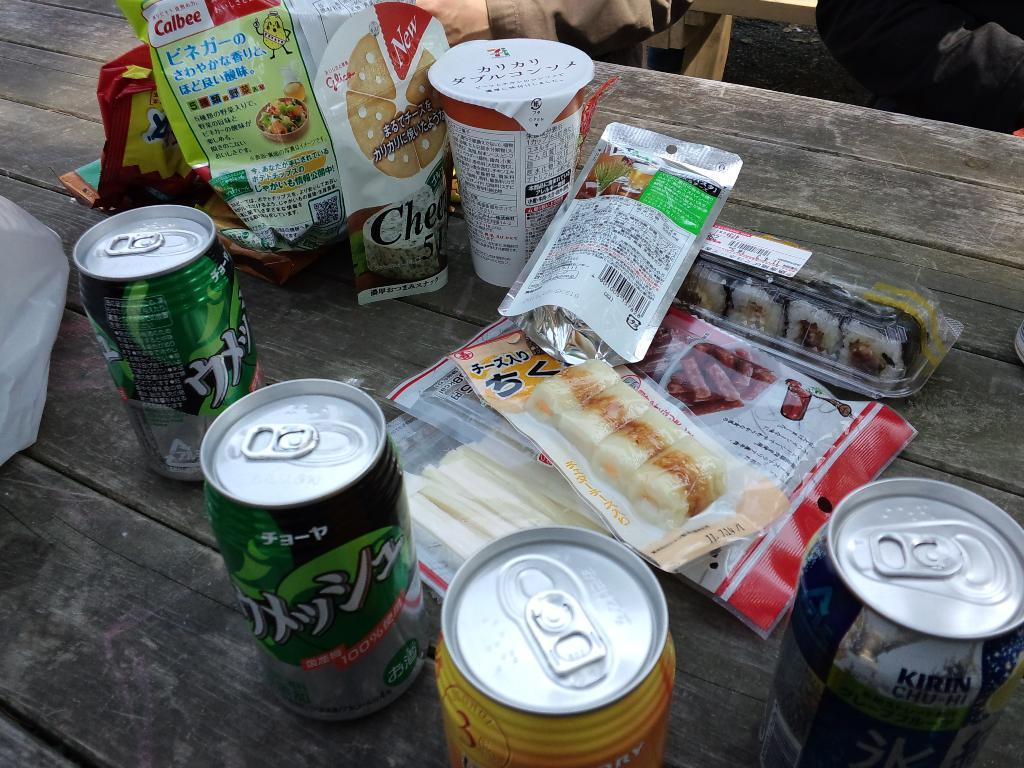<image>
Describe the image concisely. A Kirin brand drink is on the wood table. 